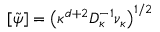<formula> <loc_0><loc_0><loc_500><loc_500>[ \tilde { \psi } ] = \left ( \kappa ^ { d + 2 } D _ { \kappa } ^ { - 1 } \nu _ { \kappa } \right ) ^ { 1 / 2 }</formula> 